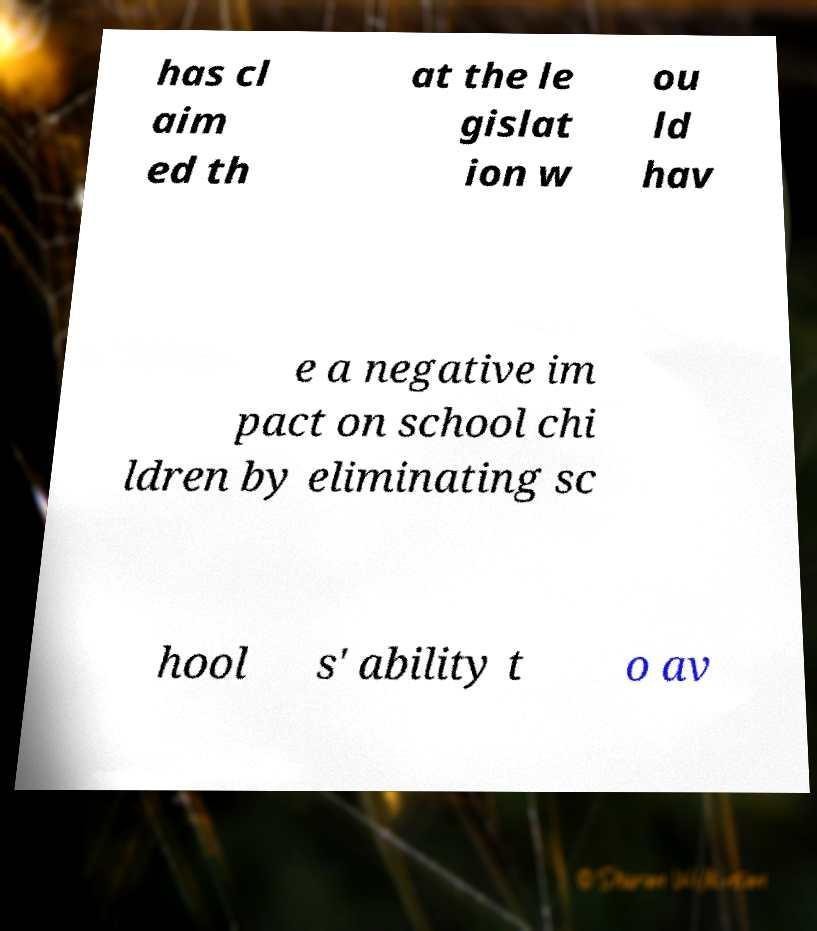I need the written content from this picture converted into text. Can you do that? has cl aim ed th at the le gislat ion w ou ld hav e a negative im pact on school chi ldren by eliminating sc hool s' ability t o av 